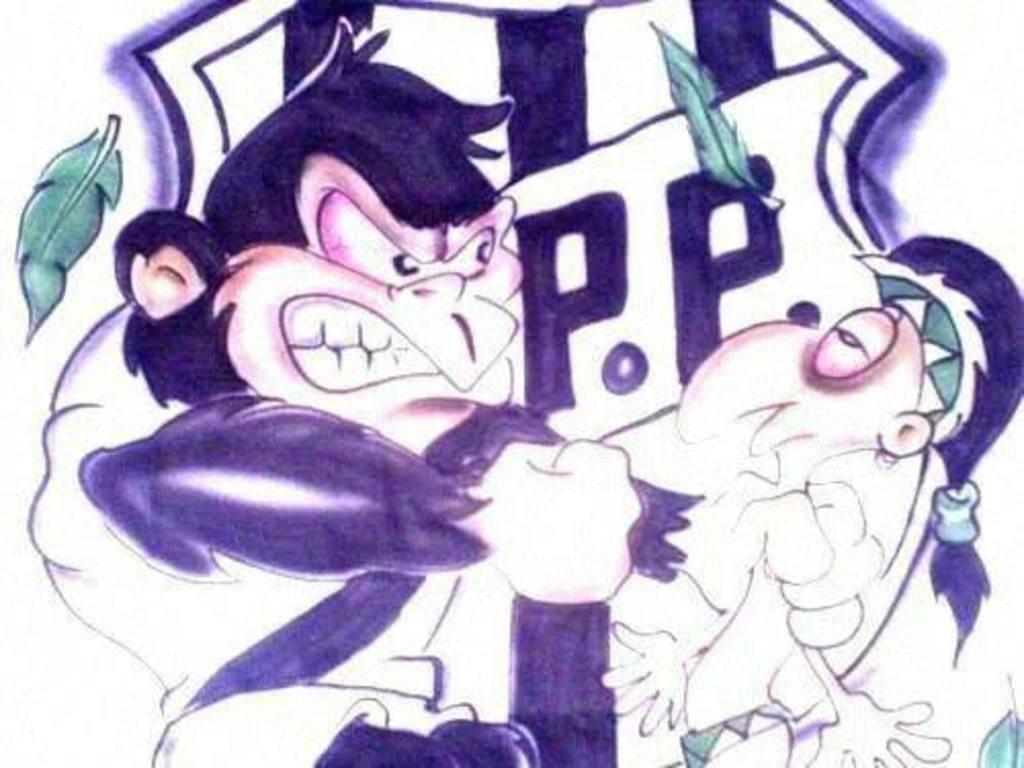In one or two sentences, can you explain what this image depicts? In the image there is a monkey punching a human, this is a painting. 